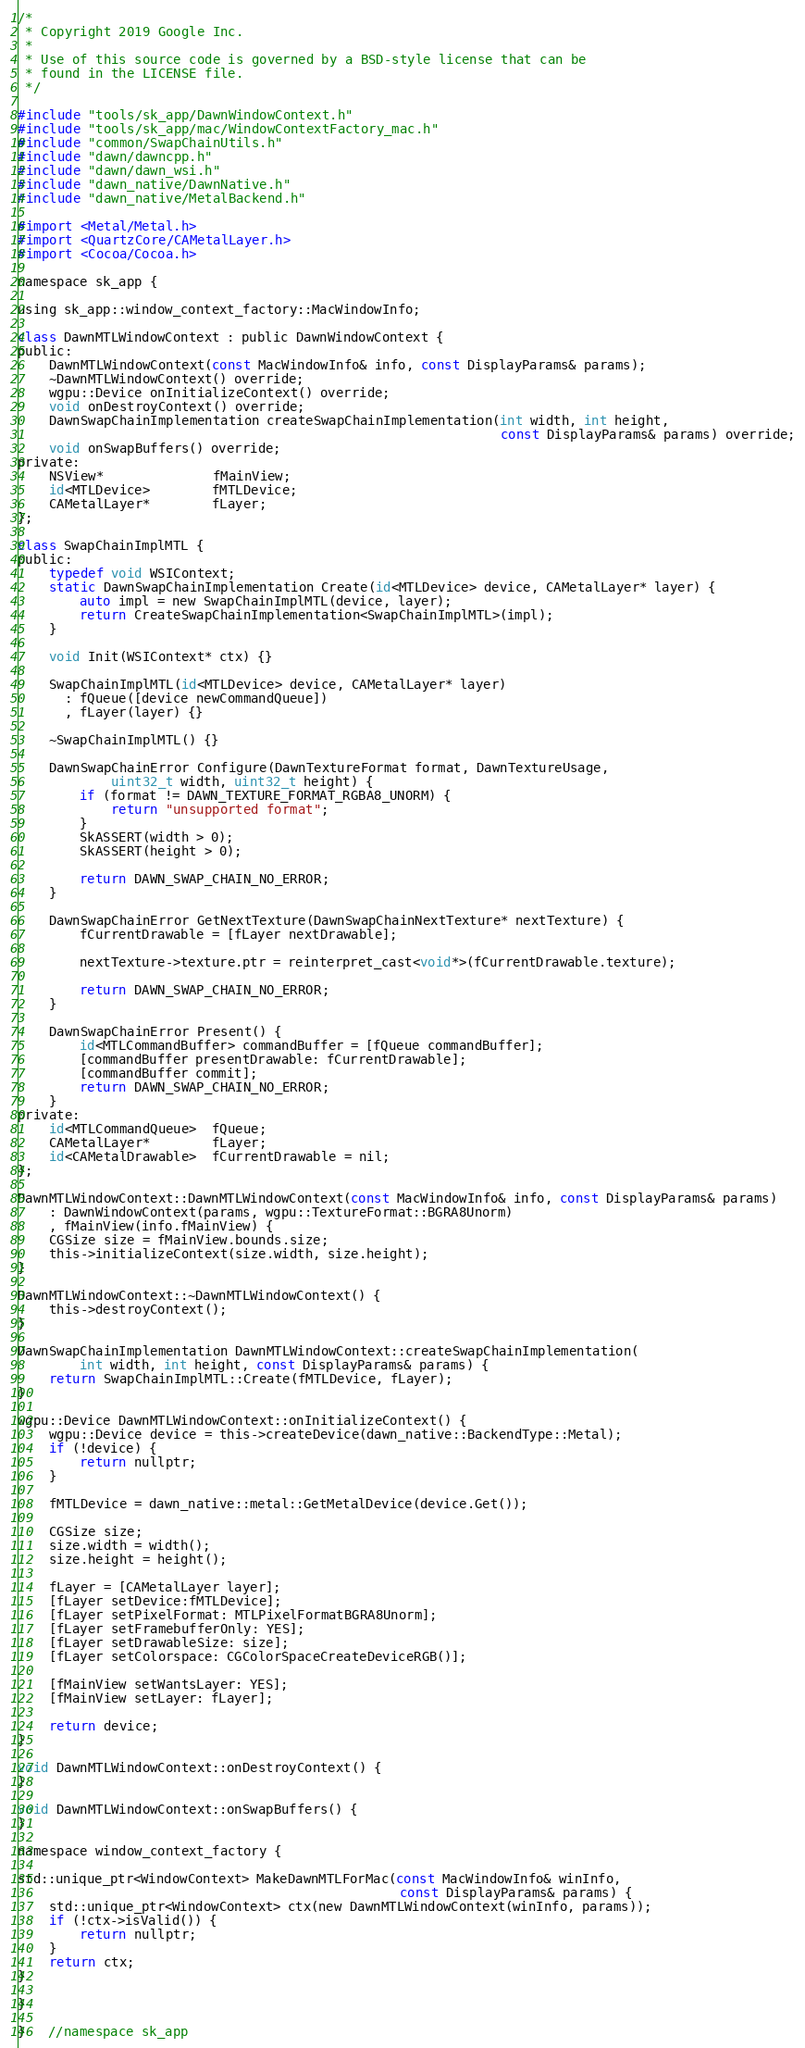<code> <loc_0><loc_0><loc_500><loc_500><_ObjectiveC_>/*
 * Copyright 2019 Google Inc.
 *
 * Use of this source code is governed by a BSD-style license that can be
 * found in the LICENSE file.
 */

#include "tools/sk_app/DawnWindowContext.h"
#include "tools/sk_app/mac/WindowContextFactory_mac.h"
#include "common/SwapChainUtils.h"
#include "dawn/dawncpp.h"
#include "dawn/dawn_wsi.h"
#include "dawn_native/DawnNative.h"
#include "dawn_native/MetalBackend.h"

#import <Metal/Metal.h>
#import <QuartzCore/CAMetalLayer.h>
#import <Cocoa/Cocoa.h>

namespace sk_app {

using sk_app::window_context_factory::MacWindowInfo;

class DawnMTLWindowContext : public DawnWindowContext {
public:
    DawnMTLWindowContext(const MacWindowInfo& info, const DisplayParams& params);
    ~DawnMTLWindowContext() override;
    wgpu::Device onInitializeContext() override;
    void onDestroyContext() override;
    DawnSwapChainImplementation createSwapChainImplementation(int width, int height,
                                                              const DisplayParams& params) override;
    void onSwapBuffers() override;
private:
    NSView*              fMainView;
    id<MTLDevice>        fMTLDevice;
    CAMetalLayer*        fLayer;
};

class SwapChainImplMTL {
public:
    typedef void WSIContext;
    static DawnSwapChainImplementation Create(id<MTLDevice> device, CAMetalLayer* layer) {
        auto impl = new SwapChainImplMTL(device, layer);
        return CreateSwapChainImplementation<SwapChainImplMTL>(impl);
    }

    void Init(WSIContext* ctx) {}

    SwapChainImplMTL(id<MTLDevice> device, CAMetalLayer* layer)
      : fQueue([device newCommandQueue])
      , fLayer(layer) {}

    ~SwapChainImplMTL() {}

    DawnSwapChainError Configure(DawnTextureFormat format, DawnTextureUsage,
            uint32_t width, uint32_t height) {
        if (format != DAWN_TEXTURE_FORMAT_RGBA8_UNORM) {
            return "unsupported format";
        }
        SkASSERT(width > 0);
        SkASSERT(height > 0);

        return DAWN_SWAP_CHAIN_NO_ERROR;
    }

    DawnSwapChainError GetNextTexture(DawnSwapChainNextTexture* nextTexture) {
        fCurrentDrawable = [fLayer nextDrawable];

        nextTexture->texture.ptr = reinterpret_cast<void*>(fCurrentDrawable.texture);

        return DAWN_SWAP_CHAIN_NO_ERROR;
    }

    DawnSwapChainError Present() {
        id<MTLCommandBuffer> commandBuffer = [fQueue commandBuffer];
        [commandBuffer presentDrawable: fCurrentDrawable];
        [commandBuffer commit];
        return DAWN_SWAP_CHAIN_NO_ERROR;
    }
private:
    id<MTLCommandQueue>  fQueue;
    CAMetalLayer*        fLayer;
    id<CAMetalDrawable>  fCurrentDrawable = nil;
};

DawnMTLWindowContext::DawnMTLWindowContext(const MacWindowInfo& info, const DisplayParams& params)
    : DawnWindowContext(params, wgpu::TextureFormat::BGRA8Unorm)
    , fMainView(info.fMainView) {
    CGSize size = fMainView.bounds.size;
    this->initializeContext(size.width, size.height);
}

DawnMTLWindowContext::~DawnMTLWindowContext() {
    this->destroyContext();
}

DawnSwapChainImplementation DawnMTLWindowContext::createSwapChainImplementation(
        int width, int height, const DisplayParams& params) {
    return SwapChainImplMTL::Create(fMTLDevice, fLayer);
}

wgpu::Device DawnMTLWindowContext::onInitializeContext() {
    wgpu::Device device = this->createDevice(dawn_native::BackendType::Metal);
    if (!device) {
        return nullptr;
    }

    fMTLDevice = dawn_native::metal::GetMetalDevice(device.Get());

    CGSize size;
    size.width = width();
    size.height = height();

    fLayer = [CAMetalLayer layer];
    [fLayer setDevice:fMTLDevice];
    [fLayer setPixelFormat: MTLPixelFormatBGRA8Unorm];
    [fLayer setFramebufferOnly: YES];
    [fLayer setDrawableSize: size];
    [fLayer setColorspace: CGColorSpaceCreateDeviceRGB()];

    [fMainView setWantsLayer: YES];
    [fMainView setLayer: fLayer];

    return device;
}

void DawnMTLWindowContext::onDestroyContext() {
}

void DawnMTLWindowContext::onSwapBuffers() {
}

namespace window_context_factory {

std::unique_ptr<WindowContext> MakeDawnMTLForMac(const MacWindowInfo& winInfo,
                                                 const DisplayParams& params) {
    std::unique_ptr<WindowContext> ctx(new DawnMTLWindowContext(winInfo, params));
    if (!ctx->isValid()) {
        return nullptr;
    }
    return ctx;
}

}

}   //namespace sk_app
</code> 